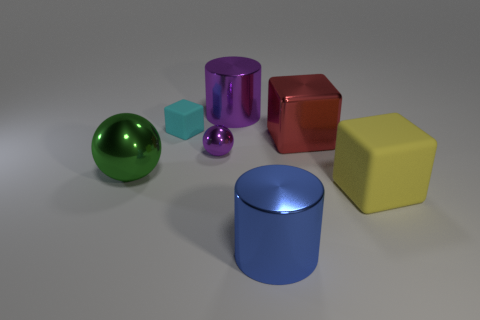Add 1 red shiny objects. How many objects exist? 8 Subtract all spheres. How many objects are left? 5 Subtract 0 red cylinders. How many objects are left? 7 Subtract all red cubes. Subtract all purple things. How many objects are left? 4 Add 1 big rubber objects. How many big rubber objects are left? 2 Add 7 cyan objects. How many cyan objects exist? 8 